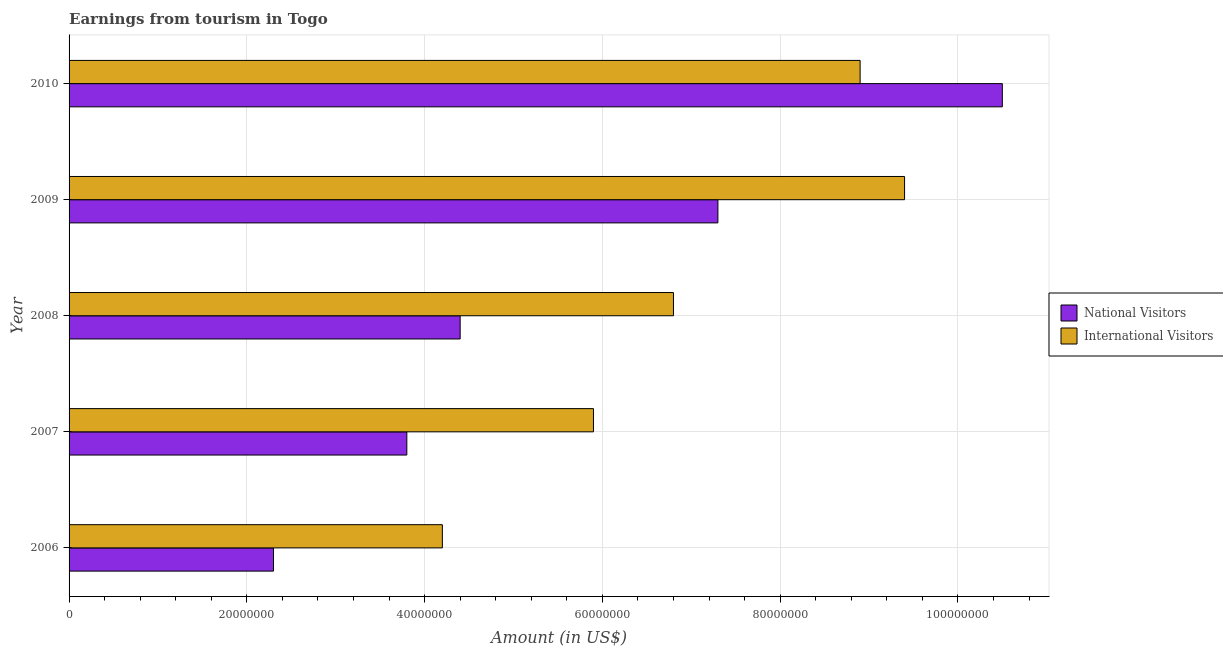Are the number of bars on each tick of the Y-axis equal?
Give a very brief answer. Yes. How many bars are there on the 3rd tick from the bottom?
Your answer should be very brief. 2. What is the label of the 4th group of bars from the top?
Offer a terse response. 2007. In how many cases, is the number of bars for a given year not equal to the number of legend labels?
Provide a short and direct response. 0. What is the amount earned from international visitors in 2008?
Your answer should be very brief. 6.80e+07. Across all years, what is the maximum amount earned from national visitors?
Offer a very short reply. 1.05e+08. Across all years, what is the minimum amount earned from international visitors?
Provide a short and direct response. 4.20e+07. In which year was the amount earned from international visitors maximum?
Keep it short and to the point. 2009. What is the total amount earned from international visitors in the graph?
Keep it short and to the point. 3.52e+08. What is the difference between the amount earned from national visitors in 2006 and that in 2008?
Your response must be concise. -2.10e+07. What is the difference between the amount earned from national visitors in 2009 and the amount earned from international visitors in 2008?
Your answer should be compact. 5.00e+06. What is the average amount earned from national visitors per year?
Keep it short and to the point. 5.66e+07. In the year 2007, what is the difference between the amount earned from national visitors and amount earned from international visitors?
Offer a terse response. -2.10e+07. In how many years, is the amount earned from national visitors greater than 96000000 US$?
Offer a terse response. 1. What is the ratio of the amount earned from international visitors in 2007 to that in 2010?
Offer a very short reply. 0.66. What is the difference between the highest and the second highest amount earned from national visitors?
Ensure brevity in your answer.  3.20e+07. What is the difference between the highest and the lowest amount earned from national visitors?
Ensure brevity in your answer.  8.20e+07. In how many years, is the amount earned from international visitors greater than the average amount earned from international visitors taken over all years?
Your answer should be compact. 2. Is the sum of the amount earned from international visitors in 2008 and 2009 greater than the maximum amount earned from national visitors across all years?
Give a very brief answer. Yes. What does the 2nd bar from the top in 2010 represents?
Give a very brief answer. National Visitors. What does the 1st bar from the bottom in 2010 represents?
Give a very brief answer. National Visitors. How many bars are there?
Give a very brief answer. 10. What is the difference between two consecutive major ticks on the X-axis?
Provide a short and direct response. 2.00e+07. How are the legend labels stacked?
Make the answer very short. Vertical. What is the title of the graph?
Your answer should be very brief. Earnings from tourism in Togo. Does "Secondary school" appear as one of the legend labels in the graph?
Offer a very short reply. No. What is the label or title of the X-axis?
Provide a succinct answer. Amount (in US$). What is the label or title of the Y-axis?
Ensure brevity in your answer.  Year. What is the Amount (in US$) of National Visitors in 2006?
Keep it short and to the point. 2.30e+07. What is the Amount (in US$) in International Visitors in 2006?
Offer a very short reply. 4.20e+07. What is the Amount (in US$) in National Visitors in 2007?
Give a very brief answer. 3.80e+07. What is the Amount (in US$) in International Visitors in 2007?
Provide a short and direct response. 5.90e+07. What is the Amount (in US$) of National Visitors in 2008?
Provide a succinct answer. 4.40e+07. What is the Amount (in US$) in International Visitors in 2008?
Provide a succinct answer. 6.80e+07. What is the Amount (in US$) of National Visitors in 2009?
Make the answer very short. 7.30e+07. What is the Amount (in US$) in International Visitors in 2009?
Ensure brevity in your answer.  9.40e+07. What is the Amount (in US$) of National Visitors in 2010?
Give a very brief answer. 1.05e+08. What is the Amount (in US$) in International Visitors in 2010?
Make the answer very short. 8.90e+07. Across all years, what is the maximum Amount (in US$) in National Visitors?
Your answer should be compact. 1.05e+08. Across all years, what is the maximum Amount (in US$) of International Visitors?
Ensure brevity in your answer.  9.40e+07. Across all years, what is the minimum Amount (in US$) of National Visitors?
Offer a very short reply. 2.30e+07. Across all years, what is the minimum Amount (in US$) in International Visitors?
Your answer should be compact. 4.20e+07. What is the total Amount (in US$) of National Visitors in the graph?
Offer a terse response. 2.83e+08. What is the total Amount (in US$) in International Visitors in the graph?
Make the answer very short. 3.52e+08. What is the difference between the Amount (in US$) in National Visitors in 2006 and that in 2007?
Make the answer very short. -1.50e+07. What is the difference between the Amount (in US$) of International Visitors in 2006 and that in 2007?
Ensure brevity in your answer.  -1.70e+07. What is the difference between the Amount (in US$) in National Visitors in 2006 and that in 2008?
Ensure brevity in your answer.  -2.10e+07. What is the difference between the Amount (in US$) in International Visitors in 2006 and that in 2008?
Keep it short and to the point. -2.60e+07. What is the difference between the Amount (in US$) of National Visitors in 2006 and that in 2009?
Ensure brevity in your answer.  -5.00e+07. What is the difference between the Amount (in US$) of International Visitors in 2006 and that in 2009?
Your answer should be very brief. -5.20e+07. What is the difference between the Amount (in US$) in National Visitors in 2006 and that in 2010?
Your response must be concise. -8.20e+07. What is the difference between the Amount (in US$) of International Visitors in 2006 and that in 2010?
Keep it short and to the point. -4.70e+07. What is the difference between the Amount (in US$) in National Visitors in 2007 and that in 2008?
Your response must be concise. -6.00e+06. What is the difference between the Amount (in US$) of International Visitors in 2007 and that in 2008?
Keep it short and to the point. -9.00e+06. What is the difference between the Amount (in US$) of National Visitors in 2007 and that in 2009?
Provide a succinct answer. -3.50e+07. What is the difference between the Amount (in US$) in International Visitors in 2007 and that in 2009?
Offer a very short reply. -3.50e+07. What is the difference between the Amount (in US$) of National Visitors in 2007 and that in 2010?
Your answer should be very brief. -6.70e+07. What is the difference between the Amount (in US$) of International Visitors in 2007 and that in 2010?
Your answer should be very brief. -3.00e+07. What is the difference between the Amount (in US$) of National Visitors in 2008 and that in 2009?
Ensure brevity in your answer.  -2.90e+07. What is the difference between the Amount (in US$) of International Visitors in 2008 and that in 2009?
Your response must be concise. -2.60e+07. What is the difference between the Amount (in US$) in National Visitors in 2008 and that in 2010?
Your answer should be very brief. -6.10e+07. What is the difference between the Amount (in US$) of International Visitors in 2008 and that in 2010?
Give a very brief answer. -2.10e+07. What is the difference between the Amount (in US$) of National Visitors in 2009 and that in 2010?
Keep it short and to the point. -3.20e+07. What is the difference between the Amount (in US$) in National Visitors in 2006 and the Amount (in US$) in International Visitors in 2007?
Provide a succinct answer. -3.60e+07. What is the difference between the Amount (in US$) of National Visitors in 2006 and the Amount (in US$) of International Visitors in 2008?
Give a very brief answer. -4.50e+07. What is the difference between the Amount (in US$) of National Visitors in 2006 and the Amount (in US$) of International Visitors in 2009?
Give a very brief answer. -7.10e+07. What is the difference between the Amount (in US$) of National Visitors in 2006 and the Amount (in US$) of International Visitors in 2010?
Keep it short and to the point. -6.60e+07. What is the difference between the Amount (in US$) in National Visitors in 2007 and the Amount (in US$) in International Visitors in 2008?
Your answer should be compact. -3.00e+07. What is the difference between the Amount (in US$) in National Visitors in 2007 and the Amount (in US$) in International Visitors in 2009?
Provide a succinct answer. -5.60e+07. What is the difference between the Amount (in US$) of National Visitors in 2007 and the Amount (in US$) of International Visitors in 2010?
Ensure brevity in your answer.  -5.10e+07. What is the difference between the Amount (in US$) of National Visitors in 2008 and the Amount (in US$) of International Visitors in 2009?
Make the answer very short. -5.00e+07. What is the difference between the Amount (in US$) of National Visitors in 2008 and the Amount (in US$) of International Visitors in 2010?
Offer a terse response. -4.50e+07. What is the difference between the Amount (in US$) of National Visitors in 2009 and the Amount (in US$) of International Visitors in 2010?
Your response must be concise. -1.60e+07. What is the average Amount (in US$) in National Visitors per year?
Ensure brevity in your answer.  5.66e+07. What is the average Amount (in US$) of International Visitors per year?
Give a very brief answer. 7.04e+07. In the year 2006, what is the difference between the Amount (in US$) of National Visitors and Amount (in US$) of International Visitors?
Your answer should be very brief. -1.90e+07. In the year 2007, what is the difference between the Amount (in US$) in National Visitors and Amount (in US$) in International Visitors?
Your response must be concise. -2.10e+07. In the year 2008, what is the difference between the Amount (in US$) in National Visitors and Amount (in US$) in International Visitors?
Your answer should be compact. -2.40e+07. In the year 2009, what is the difference between the Amount (in US$) in National Visitors and Amount (in US$) in International Visitors?
Provide a succinct answer. -2.10e+07. In the year 2010, what is the difference between the Amount (in US$) in National Visitors and Amount (in US$) in International Visitors?
Provide a succinct answer. 1.60e+07. What is the ratio of the Amount (in US$) of National Visitors in 2006 to that in 2007?
Offer a terse response. 0.61. What is the ratio of the Amount (in US$) in International Visitors in 2006 to that in 2007?
Provide a succinct answer. 0.71. What is the ratio of the Amount (in US$) in National Visitors in 2006 to that in 2008?
Provide a short and direct response. 0.52. What is the ratio of the Amount (in US$) in International Visitors in 2006 to that in 2008?
Your response must be concise. 0.62. What is the ratio of the Amount (in US$) of National Visitors in 2006 to that in 2009?
Your answer should be compact. 0.32. What is the ratio of the Amount (in US$) in International Visitors in 2006 to that in 2009?
Your answer should be very brief. 0.45. What is the ratio of the Amount (in US$) of National Visitors in 2006 to that in 2010?
Give a very brief answer. 0.22. What is the ratio of the Amount (in US$) of International Visitors in 2006 to that in 2010?
Offer a very short reply. 0.47. What is the ratio of the Amount (in US$) of National Visitors in 2007 to that in 2008?
Offer a terse response. 0.86. What is the ratio of the Amount (in US$) in International Visitors in 2007 to that in 2008?
Make the answer very short. 0.87. What is the ratio of the Amount (in US$) of National Visitors in 2007 to that in 2009?
Your answer should be very brief. 0.52. What is the ratio of the Amount (in US$) in International Visitors in 2007 to that in 2009?
Offer a terse response. 0.63. What is the ratio of the Amount (in US$) of National Visitors in 2007 to that in 2010?
Provide a succinct answer. 0.36. What is the ratio of the Amount (in US$) in International Visitors in 2007 to that in 2010?
Give a very brief answer. 0.66. What is the ratio of the Amount (in US$) in National Visitors in 2008 to that in 2009?
Your answer should be very brief. 0.6. What is the ratio of the Amount (in US$) in International Visitors in 2008 to that in 2009?
Your answer should be compact. 0.72. What is the ratio of the Amount (in US$) in National Visitors in 2008 to that in 2010?
Provide a short and direct response. 0.42. What is the ratio of the Amount (in US$) of International Visitors in 2008 to that in 2010?
Offer a terse response. 0.76. What is the ratio of the Amount (in US$) of National Visitors in 2009 to that in 2010?
Offer a very short reply. 0.7. What is the ratio of the Amount (in US$) of International Visitors in 2009 to that in 2010?
Provide a succinct answer. 1.06. What is the difference between the highest and the second highest Amount (in US$) of National Visitors?
Offer a terse response. 3.20e+07. What is the difference between the highest and the second highest Amount (in US$) of International Visitors?
Make the answer very short. 5.00e+06. What is the difference between the highest and the lowest Amount (in US$) in National Visitors?
Provide a short and direct response. 8.20e+07. What is the difference between the highest and the lowest Amount (in US$) of International Visitors?
Offer a very short reply. 5.20e+07. 